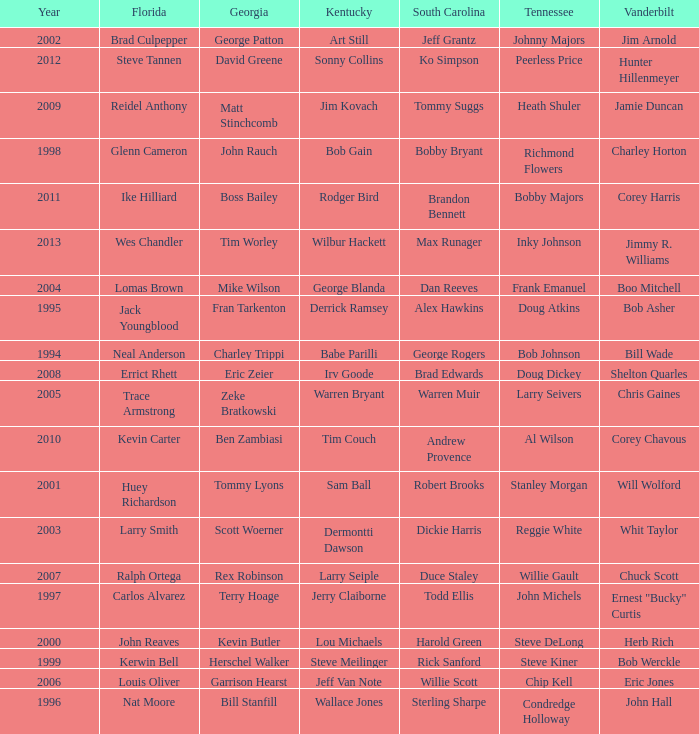What is the total Year of jeff van note ( Kentucky) 2006.0. 